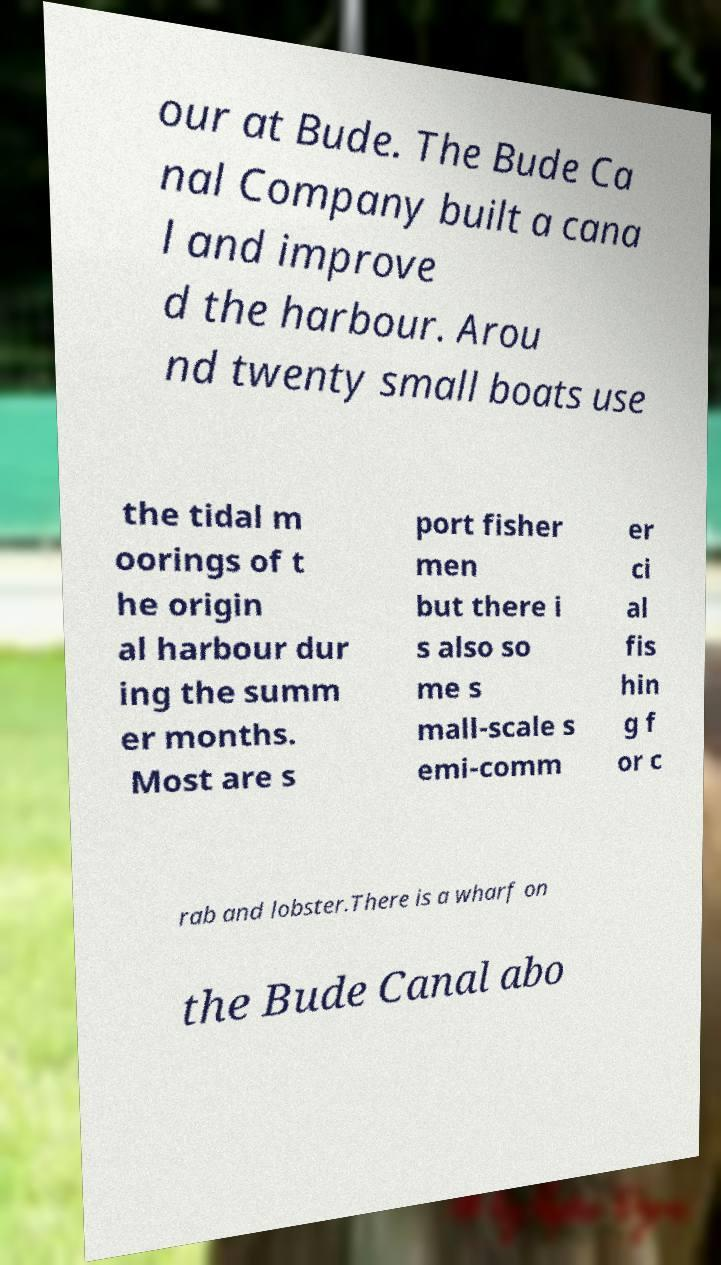Could you extract and type out the text from this image? our at Bude. The Bude Ca nal Company built a cana l and improve d the harbour. Arou nd twenty small boats use the tidal m oorings of t he origin al harbour dur ing the summ er months. Most are s port fisher men but there i s also so me s mall-scale s emi-comm er ci al fis hin g f or c rab and lobster.There is a wharf on the Bude Canal abo 